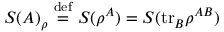Convert formula to latex. <formula><loc_0><loc_0><loc_500><loc_500>S ( A ) _ { \rho } \ { \stackrel { d e f } { = } } \ S ( \rho ^ { A } ) = S ( t r _ { B } \rho ^ { A B } )</formula> 